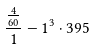<formula> <loc_0><loc_0><loc_500><loc_500>\frac { \frac { 4 } { 6 0 } } { 1 } - 1 ^ { 3 } \cdot 3 9 5</formula> 